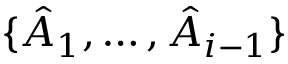<formula> <loc_0><loc_0><loc_500><loc_500>\{ \hat { A } _ { 1 } , \dots c , \hat { A } _ { i - 1 } \}</formula> 